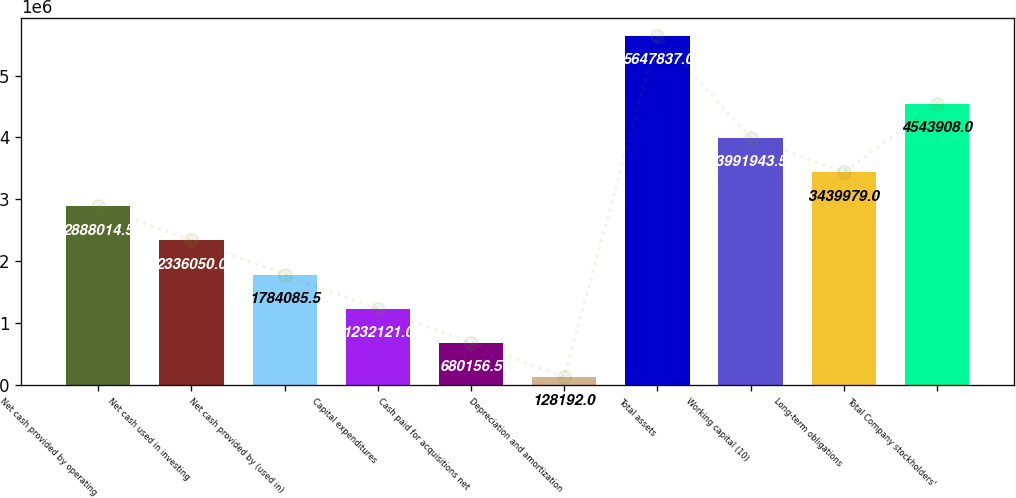Convert chart to OTSL. <chart><loc_0><loc_0><loc_500><loc_500><bar_chart><fcel>Net cash provided by operating<fcel>Net cash used in investing<fcel>Net cash provided by (used in)<fcel>Capital expenditures<fcel>Cash paid for acquisitions net<fcel>Depreciation and amortization<fcel>Total assets<fcel>Working capital (10)<fcel>Long-term obligations<fcel>Total Company stockholders'<nl><fcel>2.88801e+06<fcel>2.33605e+06<fcel>1.78409e+06<fcel>1.23212e+06<fcel>680156<fcel>128192<fcel>5.64784e+06<fcel>3.99194e+06<fcel>3.43998e+06<fcel>4.54391e+06<nl></chart> 